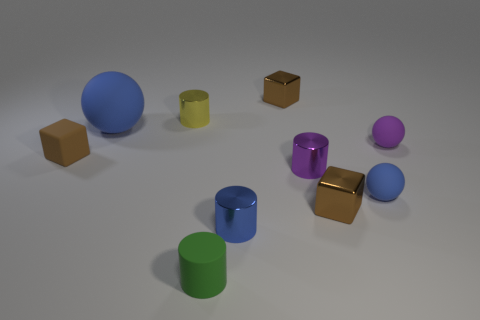What material is the green cylinder that is the same size as the purple sphere?
Provide a short and direct response. Rubber. Do the tiny blue metallic thing and the big matte object have the same shape?
Keep it short and to the point. No. What is the shape of the big matte thing that is to the left of the tiny shiny cylinder in front of the small blue sphere?
Keep it short and to the point. Sphere. Are any tiny red metal spheres visible?
Make the answer very short. No. How many small brown matte blocks are behind the large object left of the tiny metallic cube behind the brown matte cube?
Ensure brevity in your answer.  0. There is a small brown rubber object; is it the same shape as the tiny blue thing that is to the right of the blue shiny thing?
Your answer should be very brief. No. Is the number of blue objects greater than the number of large red matte blocks?
Your answer should be very brief. Yes. Is there any other thing that is the same size as the purple rubber sphere?
Provide a succinct answer. Yes. Do the blue rubber thing that is left of the green cylinder and the purple metal object have the same shape?
Keep it short and to the point. No. Are there more small blue metal cylinders in front of the purple cylinder than small yellow metallic cylinders?
Offer a terse response. No. 